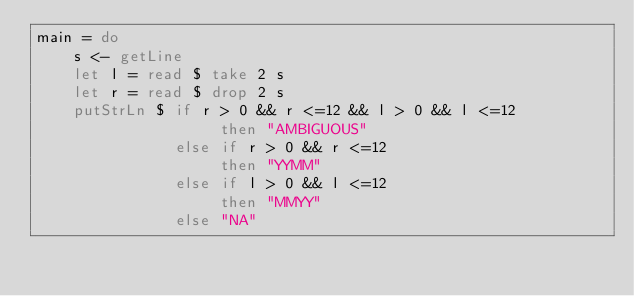Convert code to text. <code><loc_0><loc_0><loc_500><loc_500><_Haskell_>main = do
    s <- getLine
    let l = read $ take 2 s
    let r = read $ drop 2 s
    putStrLn $ if r > 0 && r <=12 && l > 0 && l <=12
                    then "AMBIGUOUS"
               else if r > 0 && r <=12
                    then "YYMM"
               else if l > 0 && l <=12
                    then "MMYY"
               else "NA"
</code> 